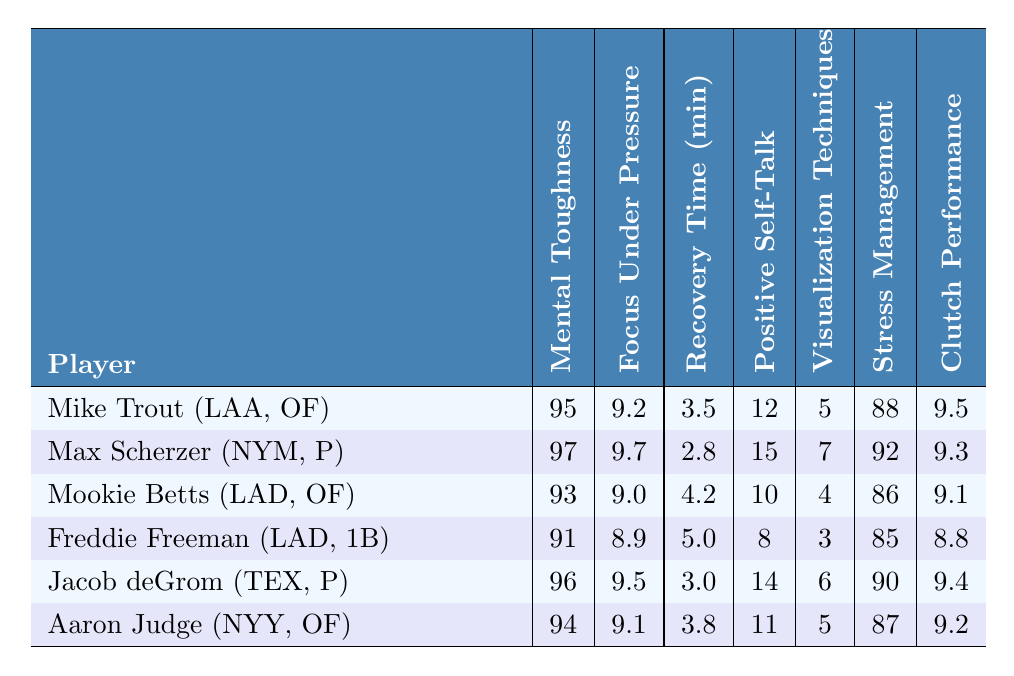What is the mental toughness score of Max Scherzer? According to the table, Max Scherzer has a mental toughness score of 97.
Answer: 97 Who has the highest focus under pressure rating? The table shows that Max Scherzer has the highest focus under pressure rating of 9.7.
Answer: 9.7 How long does Freddie Freeman take to recover after errors? The table states that Freddie Freeman's recovery time after errors is 5.0 minutes.
Answer: 5.0 minutes What is the average positive self-talk frequency for all players? To find the average, add the positive self-talk frequencies (12 + 15 + 10 + 8 + 14 + 11 = 70) and divide by the number of players (6). The average is 70/6 = 11.67.
Answer: 11.67 Which player has the lowest stress management score? Mookie Betts has the lowest stress management score, which is 86 according to the table.
Answer: 86 Is Jacob deGrom's recovery time shorter than Aaron Judge's? Jacob deGrom's recovery time is 3.0 minutes, and Aaron Judge's is 3.8 minutes. Since 3.0 is less than 3.8, Jacob deGrom's recovery time is indeed shorter.
Answer: Yes What is the difference between Max Scherzer's and Freddie Freeman's clutch performance ratings? Max Scherzer has a clutch performance rating of 9.3 and Freddie Freeman has 8.8. The difference is calculated as 9.3 - 8.8 = 0.5.
Answer: 0.5 Rank the players from highest to lowest based on mental toughness score. The players ranked from highest to lowest mental toughness score are Max Scherzer (97), Jacob deGrom (96), Mike Trout (95), Aaron Judge (94), Mookie Betts (93), and Freddie Freeman (91).
Answer: Max Scherzer, Jacob deGrom, Mike Trout, Aaron Judge, Mookie Betts, Freddie Freeman What is the total frequency of positive self-talk used by all players? Adding the frequencies (12 + 15 + 10 + 8 + 14 + 11 = 70) gives a total of 70 positive self-talk occurrences.
Answer: 70 Do any players have a mental toughness score above 95 and a stress management score below 90? The table shows that both Max Scherzer (mental toughness 97, stress management 92) and Jacob deGrom (mental toughness 96, stress management 90) have scores above 95 but not below 90. Therefore, no players meet that criterion.
Answer: No 